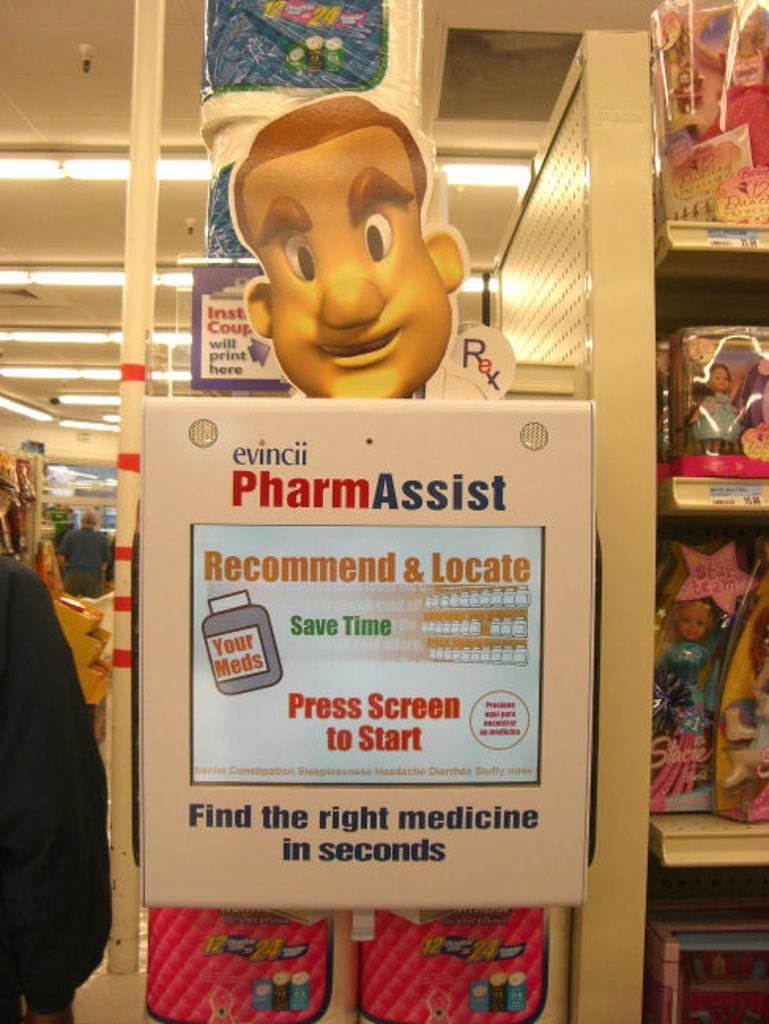Please provide a concise description of this image. In this image we can see an advertisement board, dolls packed in the polythene cartons, electric lights to the roof and people standing on the floor. 